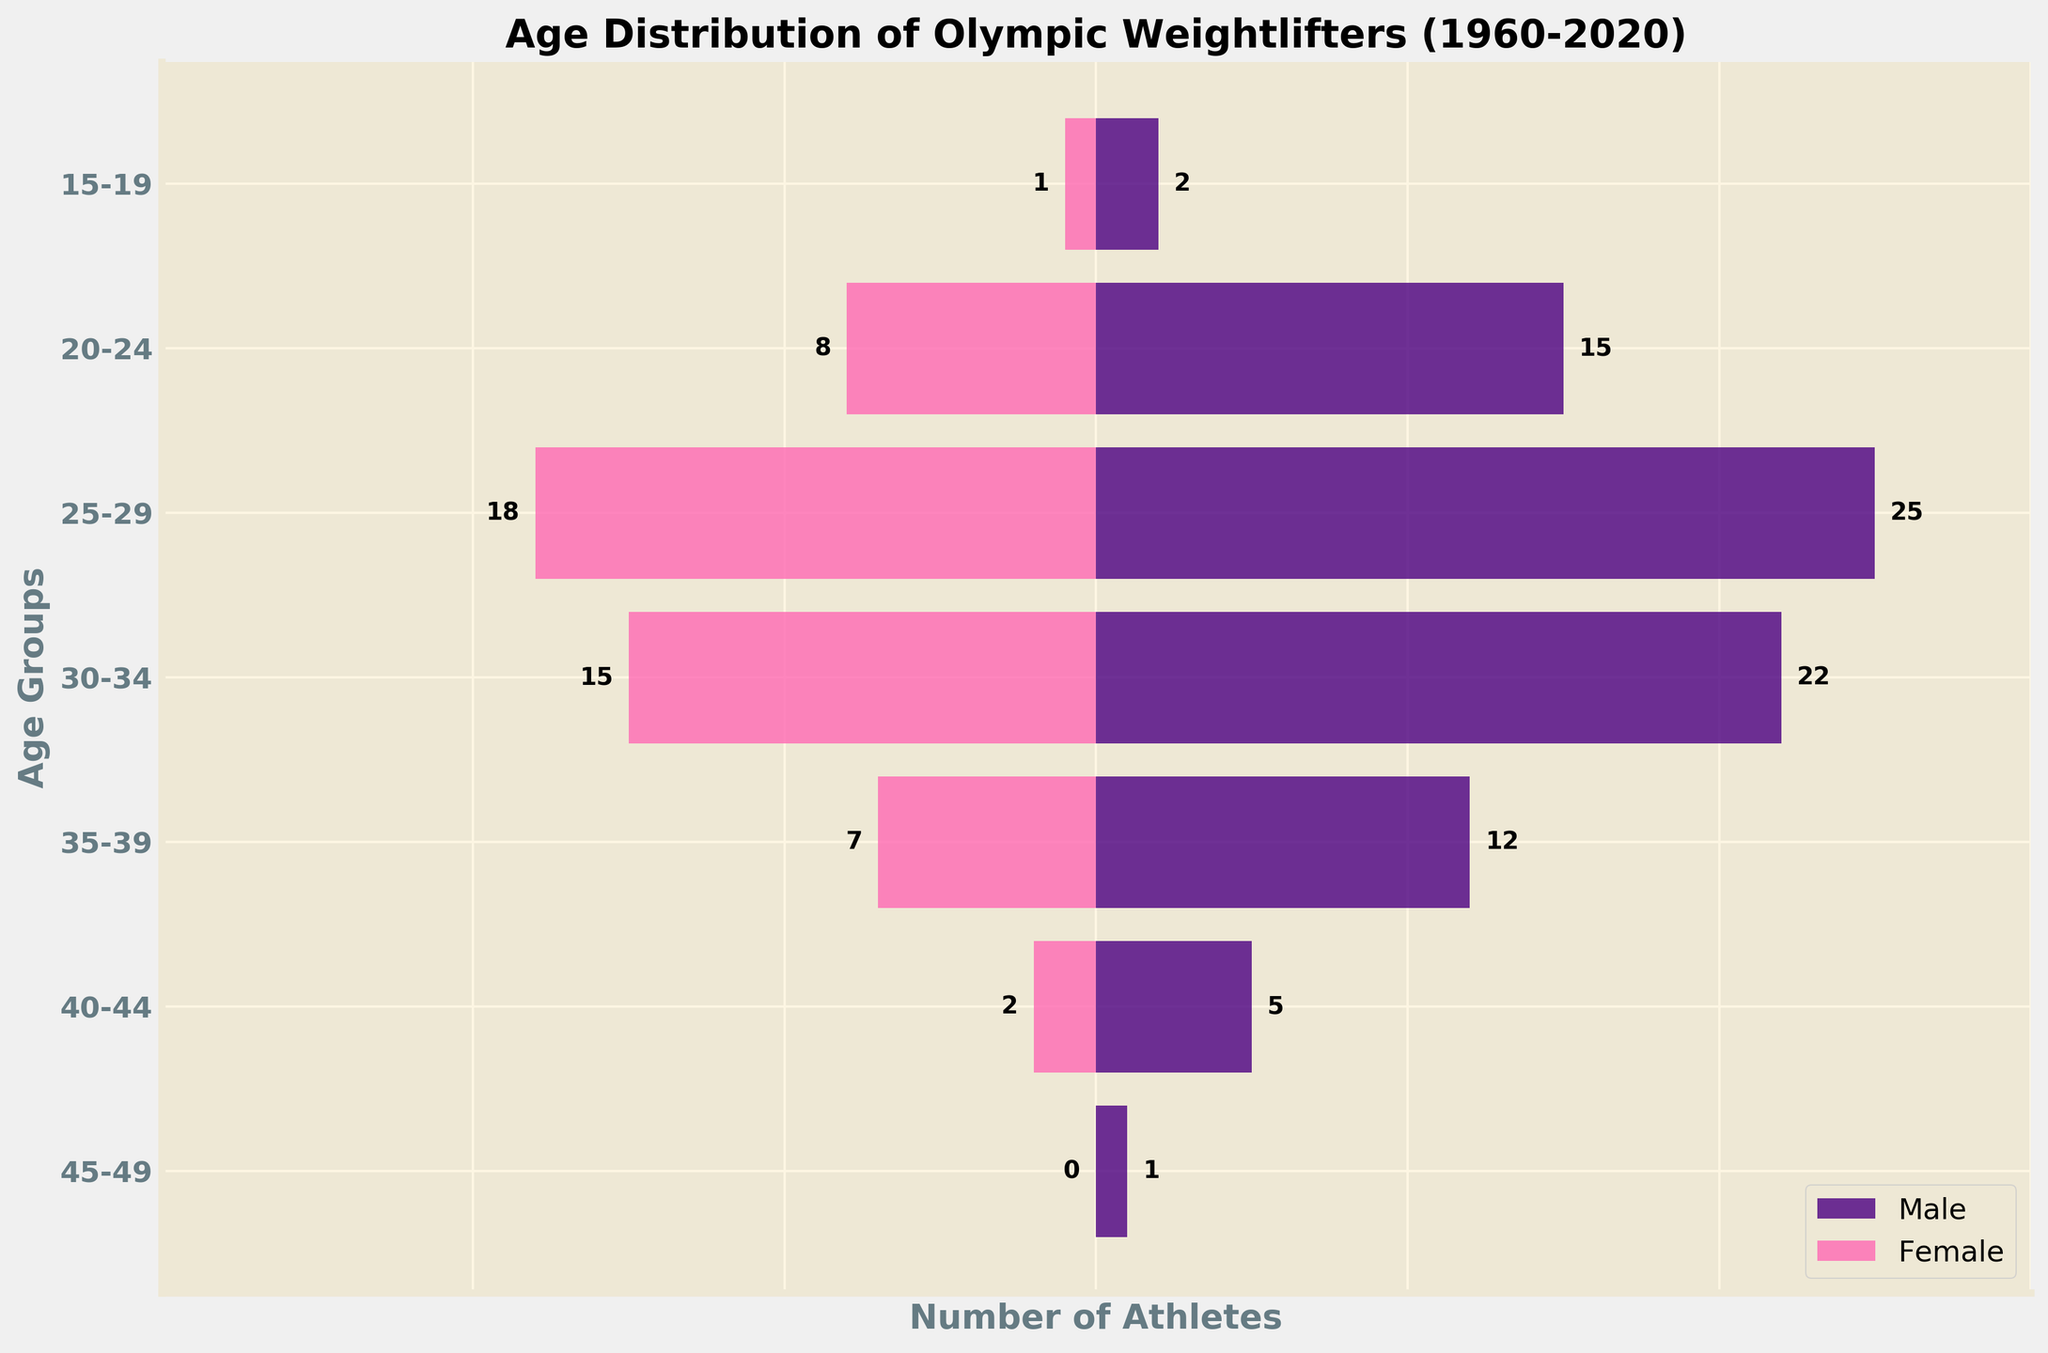What's the title of the figure? The title is located at the top of the figure. Reading it directly, it states "Age Distribution of Olympic Weightlifters (1960-2020)."
Answer: Age Distribution of Olympic Weightlifters (1960-2020) What are the labels on the x-axis and y-axis? The labels on the x-axis and y-axis are found directly beneath or beside the respective axis. The x-axis is labeled "Number of Athletes" and the y-axis is labeled "Age Groups."
Answer: Number of Athletes; Age Groups Which age group has the most male athletes? To find this, look at the bars representing male athletes. The 25-29 age group has the longest bar, indicating it has the most male athletes.
Answer: 25-29 How many male athletes are there in the 35-39 age group? Find the 35-39 age group on the y-axis, and then look at the corresponding bar length for males. The bar has a value of 12.
Answer: 12 What is the difference in the number of athletes between the 30-34 and 20-24 age groups for females? Referring to the bars for females in the 30-34 and 20-24 age groups, the values are 15 and 8, respectively. The difference is 15 - 8.
Answer: 7 In which age group do males and females have the closest number of athletes? Comparing the bars for each age group, the 15-19 age group is closest, where males have 2 and females have 1 athlete.
Answer: 15-19 What is the total number of athletes in the 40-44 age group? To find the total, sum the values for males and females in the 40-44 age group. Males have 5, and females have 2. Thus, 5 + 2 = 7.
Answer: 7 Which age group has only male athletes? Any age group with no bar for females has only male athletes. In this case, the 45-49 age group has 1 male and 0 females.
Answer: 45-49 By looking at the overall distribution, which gender has more representation in most age groups? Comparing the bars for each age group, males consistently have longer bars than females, indicating greater representation.
Answer: Males Which age group has the largest difference in the number of athletes between males and females? Calculate the absolute difference for each age group. The largest difference is in the 25-29 age group with males (25) and females (18), making the difference 25 - 18 = 7.
Answer: 25-29 